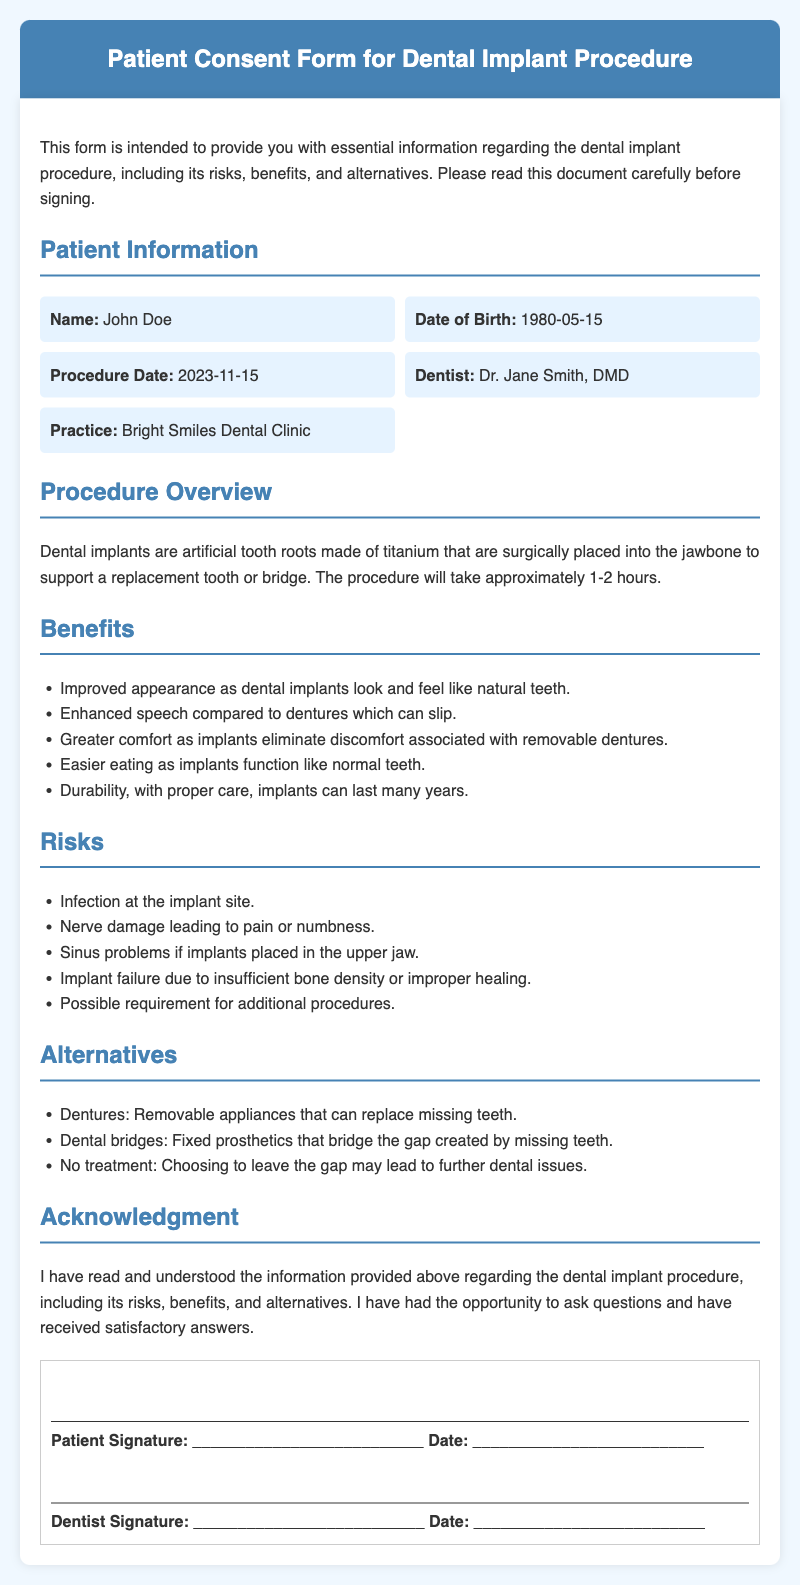What is the patient's name? The patient's name is provided in the patient information section of the document.
Answer: John Doe What is the procedure date? The procedure date can be found in the patient information section, detailing when the dental implant procedure is scheduled.
Answer: 2023-11-15 Who is the dentist performing the procedure? The dentist's name is mentioned in the patient information section of the document as the one responsible for the dental implant procedure.
Answer: Dr. Jane Smith, DMD What are the benefits of dental implants? The benefits are listed under the Benefits section in the document, summarizing the positive aspects of dental implants.
Answer: Improved appearance, enhanced speech, greater comfort, easier eating, durability What is one risk associated with dental implants? The risks are enumerated in the Risks section of the document, detailing potential complications from the procedure.
Answer: Infection at the implant site What are the alternatives to dental implants mentioned? The document outlines alternatives in a dedicated section, describing other options available for tooth replacement.
Answer: Dentures, Dental bridges, No treatment What should the patient do before signing the form? The document states that patients should read the information carefully and may ask questions before giving consent.
Answer: Read carefully and ask questions What does the acknowledgment section entail? The acknowledgment section states the patient's understanding of the procedure and their opportunity to ask questions before signing.
Answer: Understanding of risks, benefits, and alternatives 